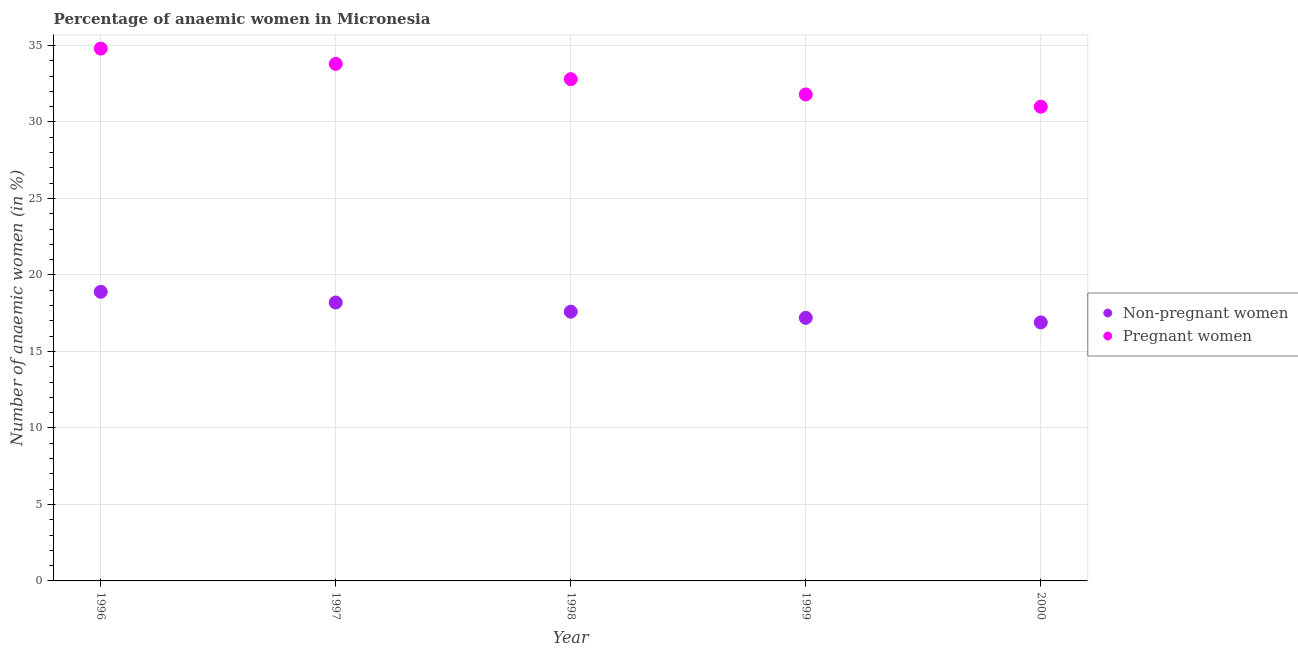What is the percentage of non-pregnant anaemic women in 1998?
Your answer should be compact. 17.6. Across all years, what is the maximum percentage of pregnant anaemic women?
Your answer should be very brief. 34.8. Across all years, what is the minimum percentage of non-pregnant anaemic women?
Ensure brevity in your answer.  16.9. In which year was the percentage of pregnant anaemic women maximum?
Offer a terse response. 1996. What is the total percentage of pregnant anaemic women in the graph?
Ensure brevity in your answer.  164.2. What is the difference between the percentage of non-pregnant anaemic women in 1999 and the percentage of pregnant anaemic women in 1996?
Make the answer very short. -17.6. What is the average percentage of non-pregnant anaemic women per year?
Ensure brevity in your answer.  17.76. In the year 1999, what is the difference between the percentage of pregnant anaemic women and percentage of non-pregnant anaemic women?
Your answer should be compact. 14.6. In how many years, is the percentage of pregnant anaemic women greater than 5 %?
Ensure brevity in your answer.  5. What is the ratio of the percentage of non-pregnant anaemic women in 1996 to that in 1998?
Give a very brief answer. 1.07. What is the difference between the highest and the lowest percentage of non-pregnant anaemic women?
Make the answer very short. 2. Is the sum of the percentage of pregnant anaemic women in 1996 and 1998 greater than the maximum percentage of non-pregnant anaemic women across all years?
Provide a succinct answer. Yes. Does the percentage of non-pregnant anaemic women monotonically increase over the years?
Your answer should be compact. No. How many years are there in the graph?
Give a very brief answer. 5. What is the difference between two consecutive major ticks on the Y-axis?
Your answer should be compact. 5. Are the values on the major ticks of Y-axis written in scientific E-notation?
Offer a terse response. No. Does the graph contain grids?
Give a very brief answer. Yes. Where does the legend appear in the graph?
Make the answer very short. Center right. What is the title of the graph?
Provide a short and direct response. Percentage of anaemic women in Micronesia. What is the label or title of the Y-axis?
Give a very brief answer. Number of anaemic women (in %). What is the Number of anaemic women (in %) in Non-pregnant women in 1996?
Offer a very short reply. 18.9. What is the Number of anaemic women (in %) of Pregnant women in 1996?
Your response must be concise. 34.8. What is the Number of anaemic women (in %) of Pregnant women in 1997?
Your answer should be compact. 33.8. What is the Number of anaemic women (in %) of Non-pregnant women in 1998?
Keep it short and to the point. 17.6. What is the Number of anaemic women (in %) in Pregnant women in 1998?
Your answer should be very brief. 32.8. What is the Number of anaemic women (in %) of Pregnant women in 1999?
Provide a succinct answer. 31.8. What is the Number of anaemic women (in %) in Non-pregnant women in 2000?
Your response must be concise. 16.9. Across all years, what is the maximum Number of anaemic women (in %) of Pregnant women?
Keep it short and to the point. 34.8. Across all years, what is the minimum Number of anaemic women (in %) of Pregnant women?
Offer a terse response. 31. What is the total Number of anaemic women (in %) of Non-pregnant women in the graph?
Your response must be concise. 88.8. What is the total Number of anaemic women (in %) in Pregnant women in the graph?
Offer a very short reply. 164.2. What is the difference between the Number of anaemic women (in %) of Non-pregnant women in 1996 and that in 1997?
Keep it short and to the point. 0.7. What is the difference between the Number of anaemic women (in %) of Pregnant women in 1996 and that in 1997?
Your response must be concise. 1. What is the difference between the Number of anaemic women (in %) of Non-pregnant women in 1997 and that in 1998?
Offer a terse response. 0.6. What is the difference between the Number of anaemic women (in %) in Non-pregnant women in 1997 and that in 1999?
Keep it short and to the point. 1. What is the difference between the Number of anaemic women (in %) of Non-pregnant women in 1997 and that in 2000?
Ensure brevity in your answer.  1.3. What is the difference between the Number of anaemic women (in %) of Pregnant women in 1997 and that in 2000?
Provide a short and direct response. 2.8. What is the difference between the Number of anaemic women (in %) of Non-pregnant women in 1998 and that in 2000?
Your response must be concise. 0.7. What is the difference between the Number of anaemic women (in %) of Non-pregnant women in 1999 and that in 2000?
Give a very brief answer. 0.3. What is the difference between the Number of anaemic women (in %) in Non-pregnant women in 1996 and the Number of anaemic women (in %) in Pregnant women in 1997?
Provide a short and direct response. -14.9. What is the difference between the Number of anaemic women (in %) in Non-pregnant women in 1996 and the Number of anaemic women (in %) in Pregnant women in 2000?
Keep it short and to the point. -12.1. What is the difference between the Number of anaemic women (in %) of Non-pregnant women in 1997 and the Number of anaemic women (in %) of Pregnant women in 1998?
Offer a terse response. -14.6. What is the difference between the Number of anaemic women (in %) in Non-pregnant women in 1997 and the Number of anaemic women (in %) in Pregnant women in 1999?
Keep it short and to the point. -13.6. What is the difference between the Number of anaemic women (in %) of Non-pregnant women in 1998 and the Number of anaemic women (in %) of Pregnant women in 2000?
Provide a succinct answer. -13.4. What is the difference between the Number of anaemic women (in %) of Non-pregnant women in 1999 and the Number of anaemic women (in %) of Pregnant women in 2000?
Give a very brief answer. -13.8. What is the average Number of anaemic women (in %) in Non-pregnant women per year?
Keep it short and to the point. 17.76. What is the average Number of anaemic women (in %) of Pregnant women per year?
Provide a short and direct response. 32.84. In the year 1996, what is the difference between the Number of anaemic women (in %) of Non-pregnant women and Number of anaemic women (in %) of Pregnant women?
Give a very brief answer. -15.9. In the year 1997, what is the difference between the Number of anaemic women (in %) in Non-pregnant women and Number of anaemic women (in %) in Pregnant women?
Ensure brevity in your answer.  -15.6. In the year 1998, what is the difference between the Number of anaemic women (in %) in Non-pregnant women and Number of anaemic women (in %) in Pregnant women?
Your response must be concise. -15.2. In the year 1999, what is the difference between the Number of anaemic women (in %) of Non-pregnant women and Number of anaemic women (in %) of Pregnant women?
Keep it short and to the point. -14.6. In the year 2000, what is the difference between the Number of anaemic women (in %) of Non-pregnant women and Number of anaemic women (in %) of Pregnant women?
Give a very brief answer. -14.1. What is the ratio of the Number of anaemic women (in %) in Pregnant women in 1996 to that in 1997?
Make the answer very short. 1.03. What is the ratio of the Number of anaemic women (in %) in Non-pregnant women in 1996 to that in 1998?
Your answer should be compact. 1.07. What is the ratio of the Number of anaemic women (in %) of Pregnant women in 1996 to that in 1998?
Your answer should be compact. 1.06. What is the ratio of the Number of anaemic women (in %) in Non-pregnant women in 1996 to that in 1999?
Your answer should be compact. 1.1. What is the ratio of the Number of anaemic women (in %) of Pregnant women in 1996 to that in 1999?
Give a very brief answer. 1.09. What is the ratio of the Number of anaemic women (in %) of Non-pregnant women in 1996 to that in 2000?
Your response must be concise. 1.12. What is the ratio of the Number of anaemic women (in %) in Pregnant women in 1996 to that in 2000?
Your answer should be compact. 1.12. What is the ratio of the Number of anaemic women (in %) in Non-pregnant women in 1997 to that in 1998?
Ensure brevity in your answer.  1.03. What is the ratio of the Number of anaemic women (in %) of Pregnant women in 1997 to that in 1998?
Offer a terse response. 1.03. What is the ratio of the Number of anaemic women (in %) of Non-pregnant women in 1997 to that in 1999?
Keep it short and to the point. 1.06. What is the ratio of the Number of anaemic women (in %) of Pregnant women in 1997 to that in 1999?
Make the answer very short. 1.06. What is the ratio of the Number of anaemic women (in %) in Pregnant women in 1997 to that in 2000?
Provide a succinct answer. 1.09. What is the ratio of the Number of anaemic women (in %) of Non-pregnant women in 1998 to that in 1999?
Keep it short and to the point. 1.02. What is the ratio of the Number of anaemic women (in %) of Pregnant women in 1998 to that in 1999?
Ensure brevity in your answer.  1.03. What is the ratio of the Number of anaemic women (in %) of Non-pregnant women in 1998 to that in 2000?
Ensure brevity in your answer.  1.04. What is the ratio of the Number of anaemic women (in %) of Pregnant women in 1998 to that in 2000?
Your response must be concise. 1.06. What is the ratio of the Number of anaemic women (in %) of Non-pregnant women in 1999 to that in 2000?
Your answer should be very brief. 1.02. What is the ratio of the Number of anaemic women (in %) of Pregnant women in 1999 to that in 2000?
Your answer should be compact. 1.03. What is the difference between the highest and the second highest Number of anaemic women (in %) of Non-pregnant women?
Your response must be concise. 0.7. What is the difference between the highest and the second highest Number of anaemic women (in %) in Pregnant women?
Your response must be concise. 1. What is the difference between the highest and the lowest Number of anaemic women (in %) in Non-pregnant women?
Offer a very short reply. 2. What is the difference between the highest and the lowest Number of anaemic women (in %) in Pregnant women?
Provide a short and direct response. 3.8. 